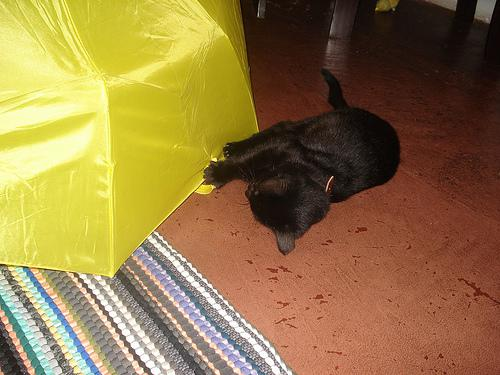Question: who is in the picture?
Choices:
A. A dog.
B. A man.
C. Kitten.
D. A baby.
Answer with the letter. Answer: C Question: how is the kitten laying?
Choices:
A. Backwards.
B. On it's paws.
C. On its side.
D. On it's belly.
Answer with the letter. Answer: C Question: what color is the kitten?
Choices:
A. White.
B. Orange and white.
C. Black.
D. Grey.
Answer with the letter. Answer: C Question: what color is the thing the kitten is playing with?
Choices:
A. Yellow.
B. Red.
C. White.
D. Blue.
Answer with the letter. Answer: A Question: what is the kitten doing?
Choices:
A. Sleeping.
B. Playing.
C. Climbing.
D. Eating.
Answer with the letter. Answer: B Question: what color is the floor?
Choices:
A. Brown.
B. Grey.
C. White.
D. Blue.
Answer with the letter. Answer: A 